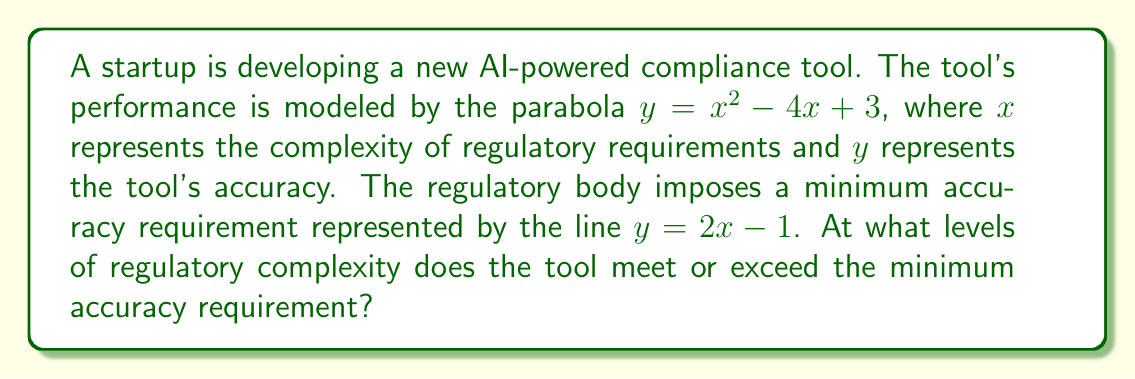Could you help me with this problem? To solve this problem, we need to find the intersection points of the parabola and the line. This can be done in the following steps:

1) The parabola equation is: $y = x^2 - 4x + 3$
   The line equation is: $y = 2x - 1$

2) At the intersection points, the y-values are equal. So we can set up the equation:
   $x^2 - 4x + 3 = 2x - 1$

3) Rearrange the equation to standard form:
   $x^2 - 6x + 4 = 0$

4) This is a quadratic equation. We can solve it using the quadratic formula:
   $x = \frac{-b \pm \sqrt{b^2 - 4ac}}{2a}$

   Where $a = 1$, $b = -6$, and $c = 4$

5) Substituting these values:
   $x = \frac{6 \pm \sqrt{36 - 16}}{2} = \frac{6 \pm \sqrt{20}}{2} = \frac{6 \pm 2\sqrt{5}}{2}$

6) Simplifying:
   $x = 3 \pm \sqrt{5}$

7) Therefore, the two solutions are:
   $x_1 = 3 + \sqrt{5}$ and $x_2 = 3 - \sqrt{5}$

These x-values represent the levels of regulatory complexity where the tool's accuracy meets the minimum requirement.
Answer: $x = 3 \pm \sqrt{5}$ 